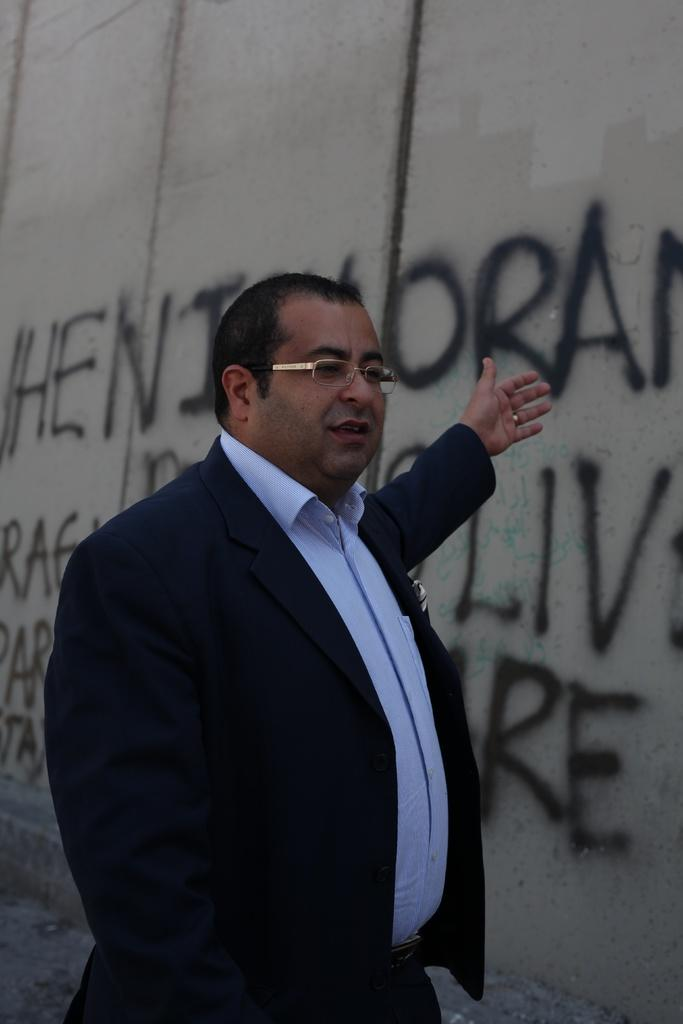Who or what is the main subject in the center of the image? There is a person in the center of the image. What is the person wearing? The person is wearing a coat and glasses. What can be seen in the background of the image? There is text on the wall in the background of the image. What type of pump is visible in the image? There is no pump present in the image. Is the person in the image at a hospital? The image does not provide any information about the location or context of the person, so it cannot be determined if they are at a hospital. 